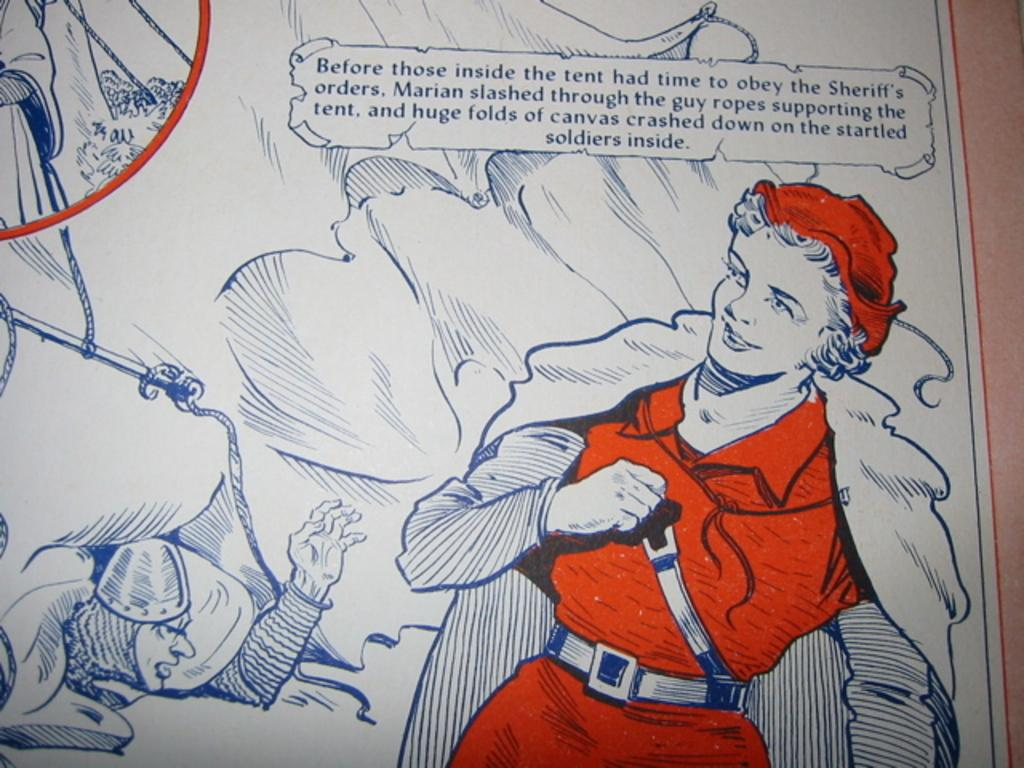<image>
Write a terse but informative summary of the picture. An illustrated picture with a caption that partly begins, "Before those inside the tent." 